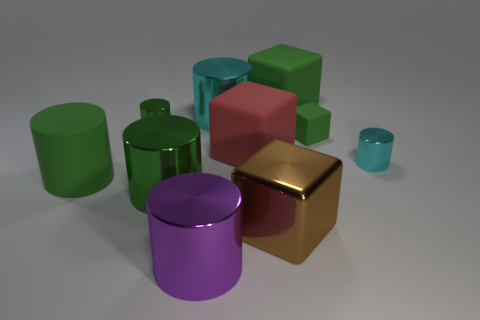Subtract all green blocks. How many green cylinders are left? 3 Subtract 2 cylinders. How many cylinders are left? 4 Subtract all purple cylinders. How many cylinders are left? 5 Subtract all big purple cylinders. How many cylinders are left? 5 Subtract all yellow cylinders. Subtract all red cubes. How many cylinders are left? 6 Subtract all cylinders. How many objects are left? 4 Subtract 0 purple blocks. How many objects are left? 10 Subtract all large red rubber blocks. Subtract all small blue rubber cylinders. How many objects are left? 9 Add 5 large green matte blocks. How many large green matte blocks are left? 6 Add 4 purple metal objects. How many purple metal objects exist? 5 